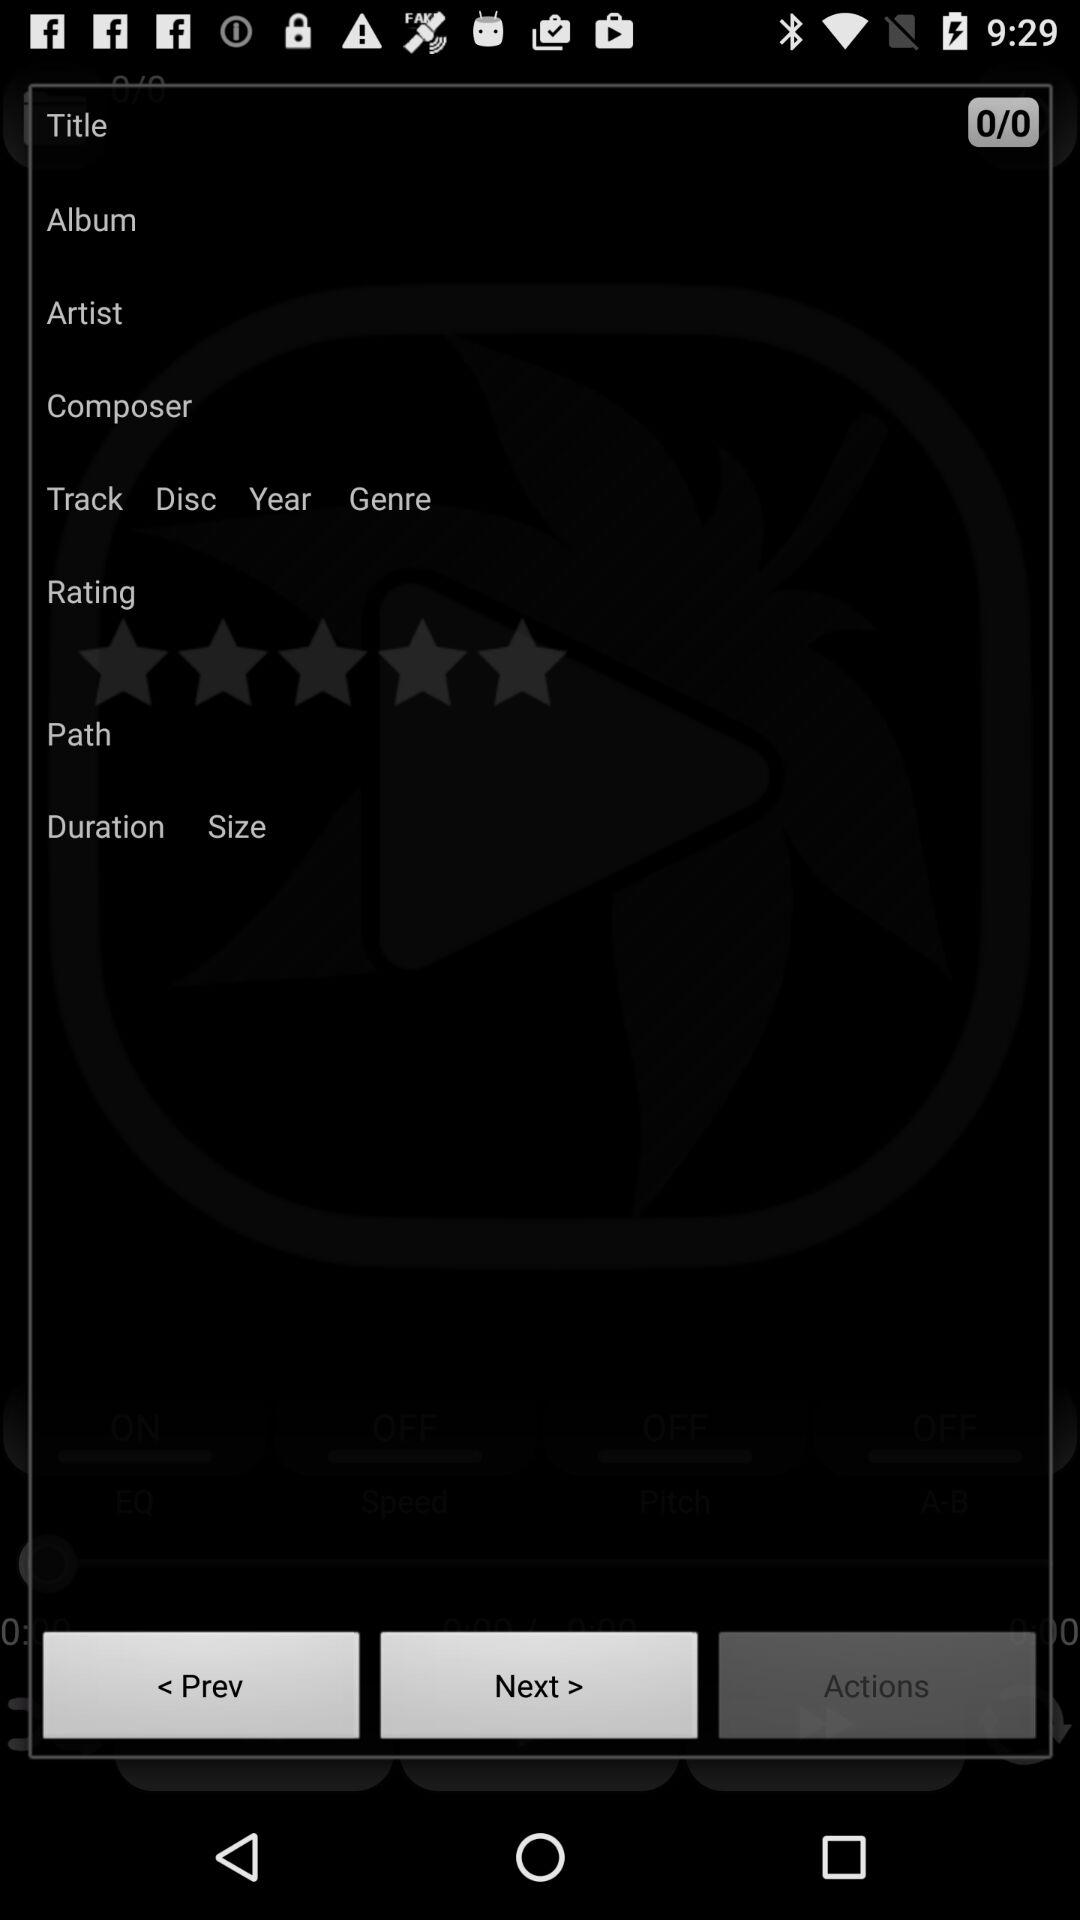How many stars does the application get?
When the provided information is insufficient, respond with <no answer>. <no answer> 